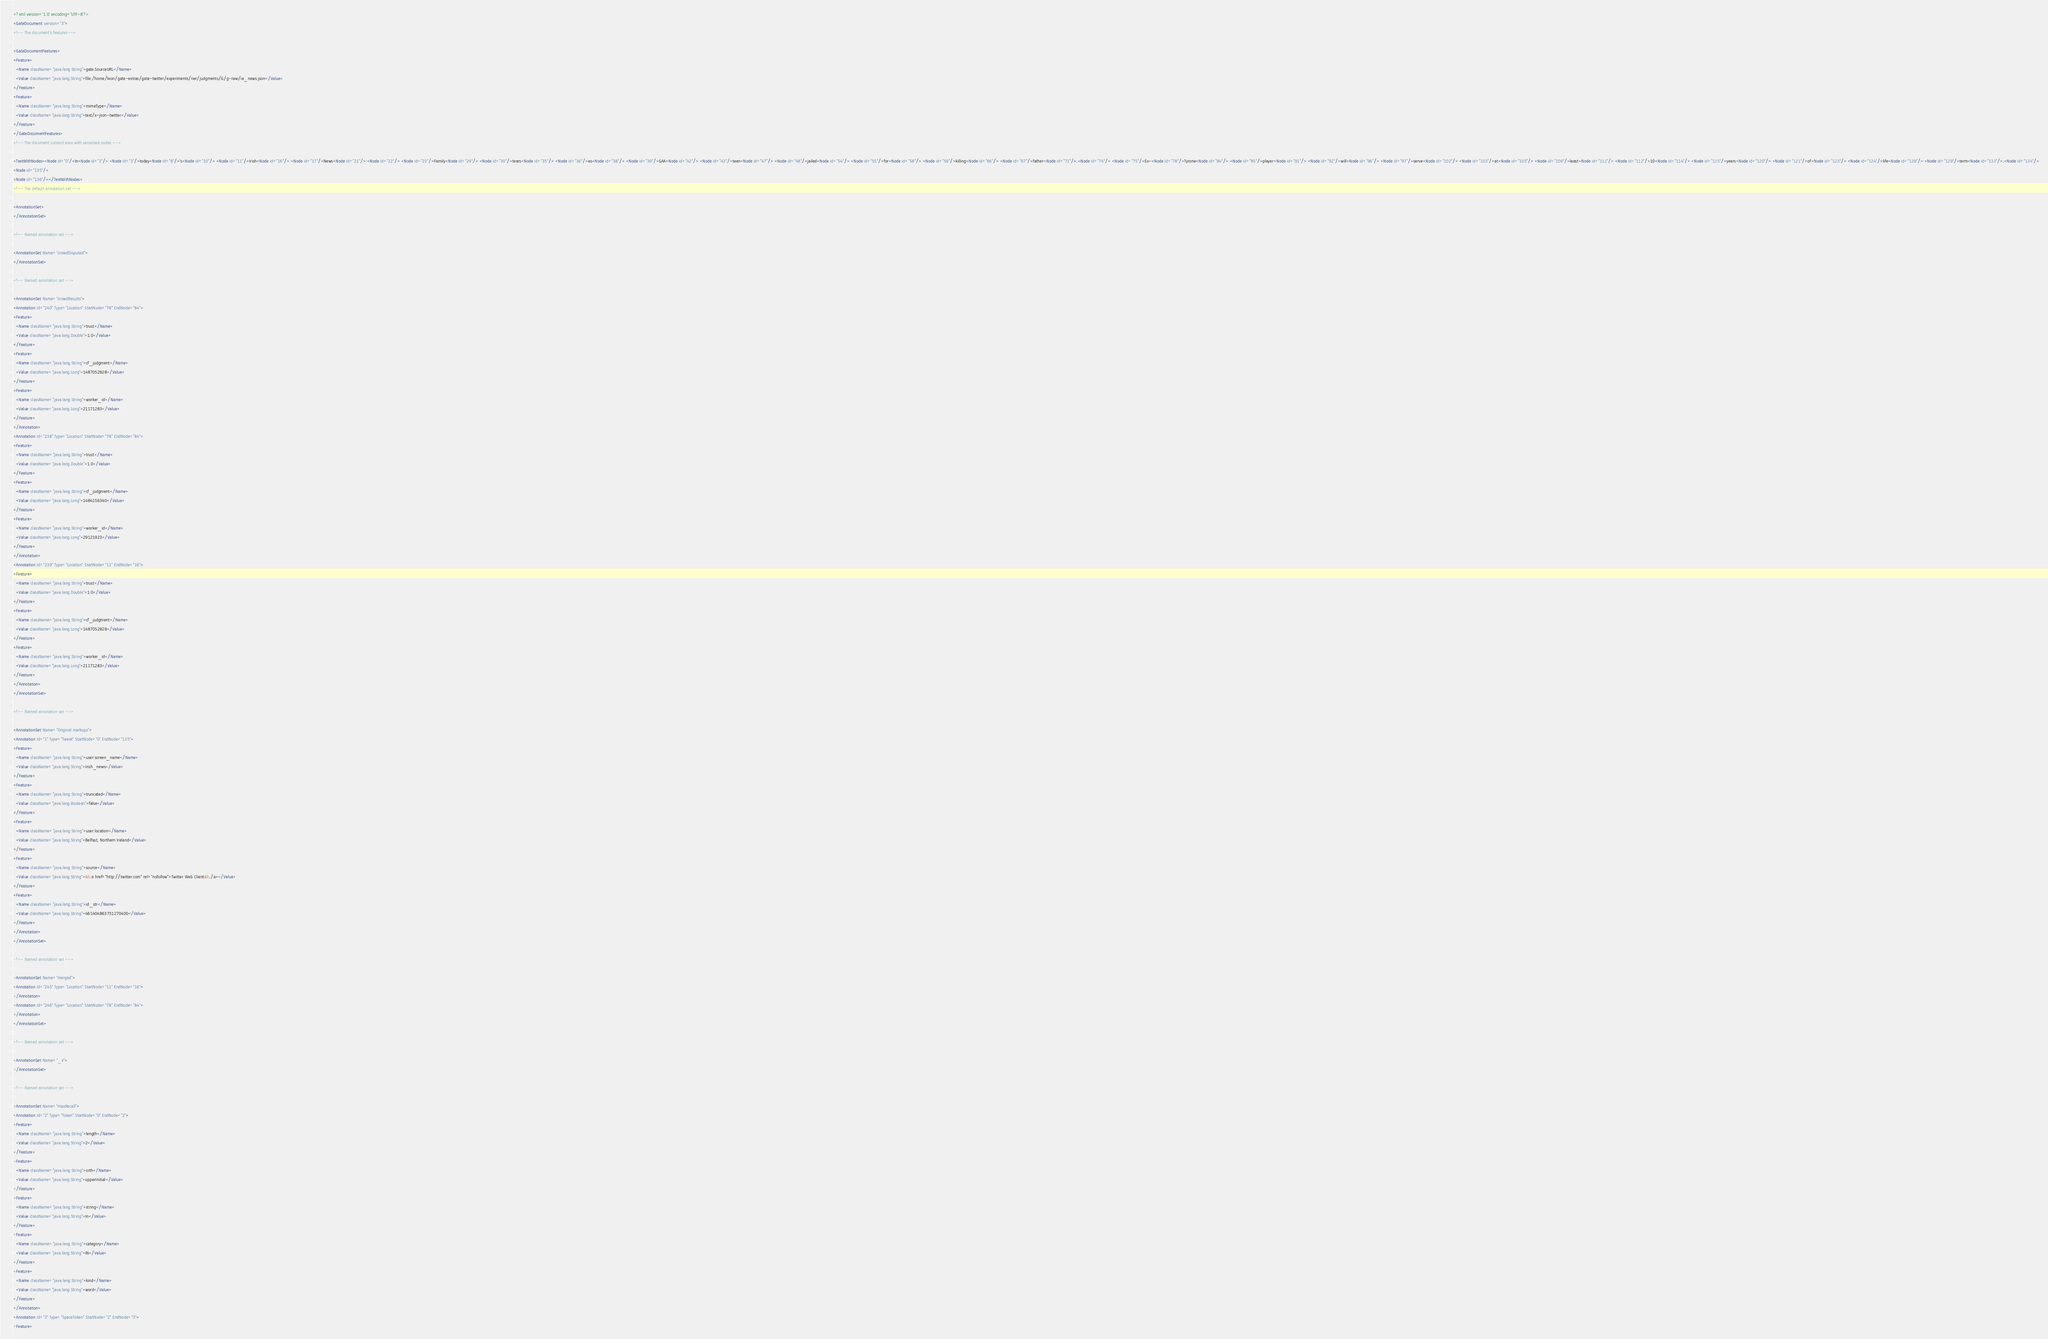<code> <loc_0><loc_0><loc_500><loc_500><_XML_><?xml version='1.0' encoding='UTF-8'?>
<GateDocument version="3">
<!-- The document's features-->

<GateDocumentFeatures>
<Feature>
  <Name className="java.lang.String">gate.SourceURL</Name>
  <Value className="java.lang.String">file:/home/leon/gate-extras/gate-twitter/experiments/ner/judgments/G/g-raw/ie_news.json</Value>
</Feature>
<Feature>
  <Name className="java.lang.String">mimeType</Name>
  <Value className="java.lang.String">text/x-json-twitter</Value>
</Feature>
</GateDocumentFeatures>
<!-- The document content area with serialized nodes -->

<TextWithNodes><Node id="0"/>In<Node id="2"/> <Node id="3"/>today<Node id="8"/>'s<Node id="10"/> <Node id="11"/>Irish<Node id="16"/> <Node id="17"/>News<Node id="21"/>:<Node id="22"/> <Node id="23"/>Family<Node id="29"/> <Node id="30"/>tears<Node id="35"/> <Node id="36"/>as<Node id="38"/> <Node id="39"/>GAA<Node id="42"/> <Node id="43"/>teen<Node id="47"/> <Node id="48"/>jailed<Node id="54"/> <Node id="55"/>for<Node id="58"/> <Node id="59"/>killing<Node id="66"/> <Node id="67"/>father<Node id="73"/>.<Node id="74"/> <Node id="75"/>Ex-<Node id="78"/>Tyrone<Node id="84"/> <Node id="85"/>player<Node id="91"/> <Node id="92"/>will<Node id="96"/> <Node id="97"/>serve<Node id="102"/> <Node id="103"/>at<Node id="105"/> <Node id="106"/>least<Node id="111"/> <Node id="112"/>10<Node id="114"/> <Node id="115"/>years<Node id="120"/> <Node id="121"/>of<Node id="123"/> <Node id="124"/>life<Node id="128"/> <Node id="129"/>term<Node id="133"/>.<Node id="134"/>
<Node id="135"/>
<Node id="136"/></TextWithNodes>
<!-- The default annotation set -->

<AnnotationSet>
</AnnotationSet>

<!-- Named annotation set -->

<AnnotationSet Name="crowdDisputed">
</AnnotationSet>

<!-- Named annotation set -->

<AnnotationSet Name="crowdResults">
<Annotation Id="240" Type="Location" StartNode="78" EndNode="84">
<Feature>
  <Name className="java.lang.String">trust</Name>
  <Value className="java.lang.Double">1.0</Value>
</Feature>
<Feature>
  <Name className="java.lang.String">cf_judgment</Name>
  <Value className="java.lang.Long">1487052828</Value>
</Feature>
<Feature>
  <Name className="java.lang.String">worker_id</Name>
  <Value className="java.lang.Long">21171283</Value>
</Feature>
</Annotation>
<Annotation Id="238" Type="Location" StartNode="78" EndNode="84">
<Feature>
  <Name className="java.lang.String">trust</Name>
  <Value className="java.lang.Double">1.0</Value>
</Feature>
<Feature>
  <Name className="java.lang.String">cf_judgment</Name>
  <Value className="java.lang.Long">1484156340</Value>
</Feature>
<Feature>
  <Name className="java.lang.String">worker_id</Name>
  <Value className="java.lang.Long">29121923</Value>
</Feature>
</Annotation>
<Annotation Id="239" Type="Location" StartNode="11" EndNode="16">
<Feature>
  <Name className="java.lang.String">trust</Name>
  <Value className="java.lang.Double">1.0</Value>
</Feature>
<Feature>
  <Name className="java.lang.String">cf_judgment</Name>
  <Value className="java.lang.Long">1487052828</Value>
</Feature>
<Feature>
  <Name className="java.lang.String">worker_id</Name>
  <Value className="java.lang.Long">21171283</Value>
</Feature>
</Annotation>
</AnnotationSet>

<!-- Named annotation set -->

<AnnotationSet Name="Original markups">
<Annotation Id="1" Type="Tweet" StartNode="0" EndNode="135">
<Feature>
  <Name className="java.lang.String">user:screen_name</Name>
  <Value className="java.lang.String">irish_news</Value>
</Feature>
<Feature>
  <Name className="java.lang.String">truncated</Name>
  <Value className="java.lang.Boolean">false</Value>
</Feature>
<Feature>
  <Name className="java.lang.String">user:location</Name>
  <Value className="java.lang.String">Belfast, Northern Ireland</Value>
</Feature>
<Feature>
  <Name className="java.lang.String">source</Name>
  <Value className="java.lang.String">&lt;a href="http://twitter.com" rel="nofollow">Twitter Web Client&lt;/a></Value>
</Feature>
<Feature>
  <Name className="java.lang.String">id_str</Name>
  <Value className="java.lang.String">461404863751270400</Value>
</Feature>
</Annotation>
</AnnotationSet>

<!-- Named annotation set -->

<AnnotationSet Name="merged">
<Annotation Id="245" Type="Location" StartNode="11" EndNode="16">
</Annotation>
<Annotation Id="246" Type="Location" StartNode="78" EndNode="84">
</Annotation>
</AnnotationSet>

<!-- Named annotation set -->

<AnnotationSet Name="_x">
</AnnotationSet>

<!-- Named annotation set -->

<AnnotationSet Name="maxRecall">
<Annotation Id="2" Type="Token" StartNode="0" EndNode="2">
<Feature>
  <Name className="java.lang.String">length</Name>
  <Value className="java.lang.String">2</Value>
</Feature>
<Feature>
  <Name className="java.lang.String">orth</Name>
  <Value className="java.lang.String">upperInitial</Value>
</Feature>
<Feature>
  <Name className="java.lang.String">string</Name>
  <Value className="java.lang.String">In</Value>
</Feature>
<Feature>
  <Name className="java.lang.String">category</Name>
  <Value className="java.lang.String">IN</Value>
</Feature>
<Feature>
  <Name className="java.lang.String">kind</Name>
  <Value className="java.lang.String">word</Value>
</Feature>
</Annotation>
<Annotation Id="3" Type="SpaceToken" StartNode="2" EndNode="3">
<Feature></code> 